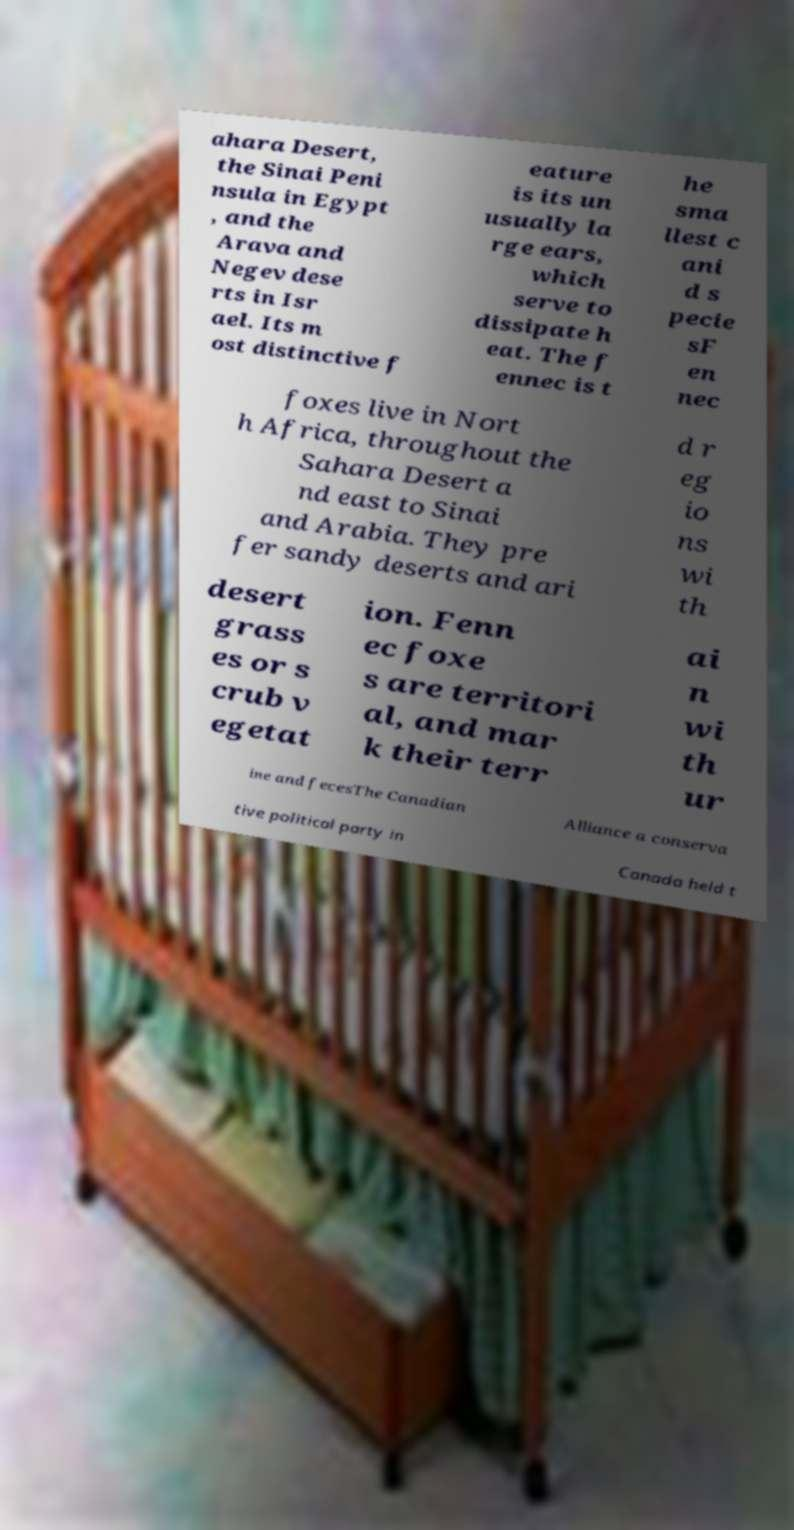Please read and relay the text visible in this image. What does it say? ahara Desert, the Sinai Peni nsula in Egypt , and the Arava and Negev dese rts in Isr ael. Its m ost distinctive f eature is its un usually la rge ears, which serve to dissipate h eat. The f ennec is t he sma llest c ani d s pecie sF en nec foxes live in Nort h Africa, throughout the Sahara Desert a nd east to Sinai and Arabia. They pre fer sandy deserts and ari d r eg io ns wi th desert grass es or s crub v egetat ion. Fenn ec foxe s are territori al, and mar k their terr ai n wi th ur ine and fecesThe Canadian Alliance a conserva tive political party in Canada held t 